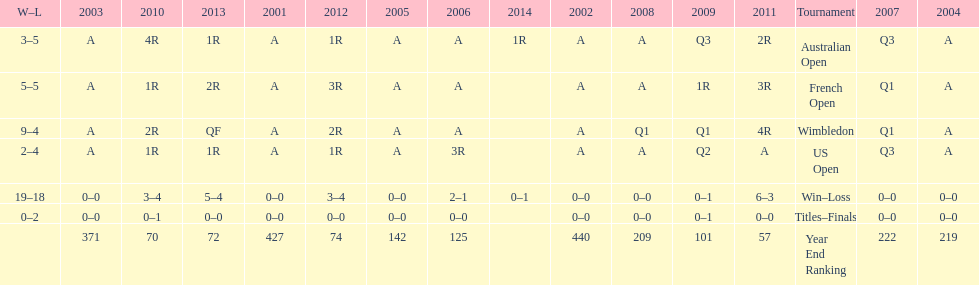Which years was a ranking below 200 achieved? 2005, 2006, 2009, 2010, 2011, 2012, 2013. 